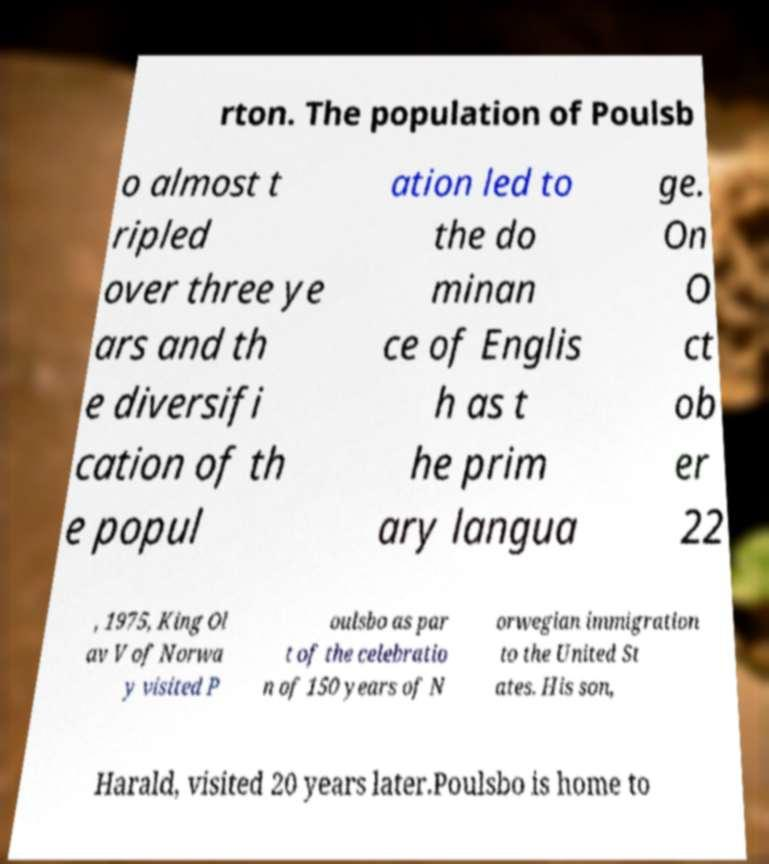Can you accurately transcribe the text from the provided image for me? rton. The population of Poulsb o almost t ripled over three ye ars and th e diversifi cation of th e popul ation led to the do minan ce of Englis h as t he prim ary langua ge. On O ct ob er 22 , 1975, King Ol av V of Norwa y visited P oulsbo as par t of the celebratio n of 150 years of N orwegian immigration to the United St ates. His son, Harald, visited 20 years later.Poulsbo is home to 